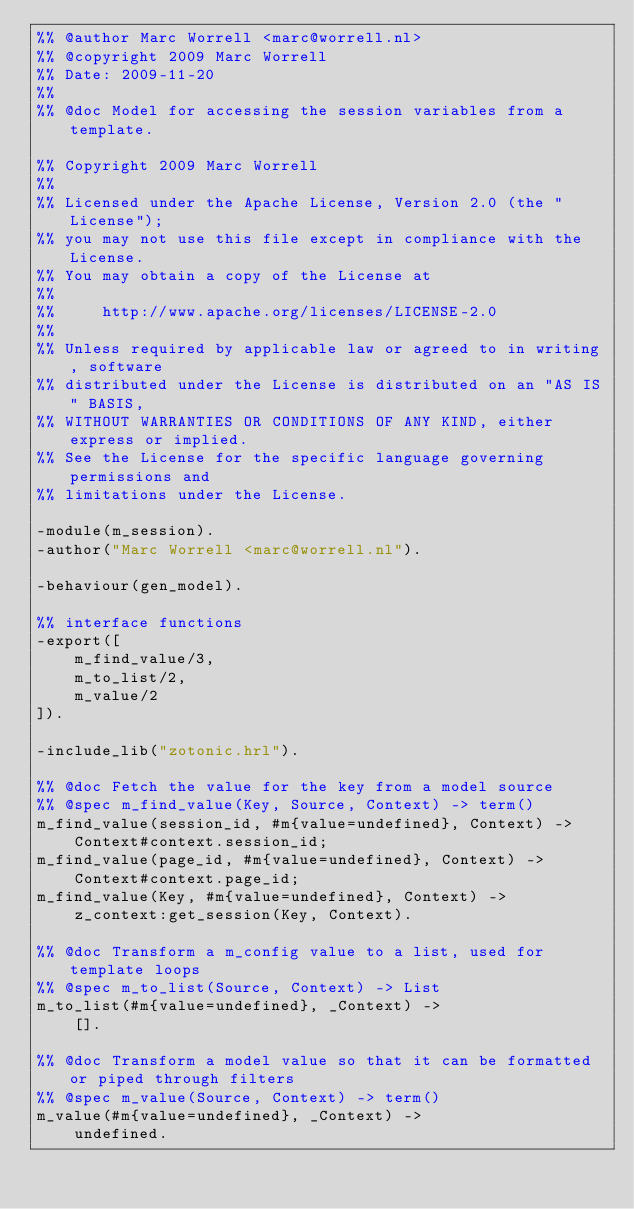Convert code to text. <code><loc_0><loc_0><loc_500><loc_500><_Erlang_>%% @author Marc Worrell <marc@worrell.nl>
%% @copyright 2009 Marc Worrell
%% Date: 2009-11-20
%%
%% @doc Model for accessing the session variables from a template.

%% Copyright 2009 Marc Worrell
%%
%% Licensed under the Apache License, Version 2.0 (the "License");
%% you may not use this file except in compliance with the License.
%% You may obtain a copy of the License at
%%
%%     http://www.apache.org/licenses/LICENSE-2.0
%%
%% Unless required by applicable law or agreed to in writing, software
%% distributed under the License is distributed on an "AS IS" BASIS,
%% WITHOUT WARRANTIES OR CONDITIONS OF ANY KIND, either express or implied.
%% See the License for the specific language governing permissions and
%% limitations under the License.

-module(m_session).
-author("Marc Worrell <marc@worrell.nl").

-behaviour(gen_model).

%% interface functions
-export([
    m_find_value/3,
    m_to_list/2,
    m_value/2
]).

-include_lib("zotonic.hrl").

%% @doc Fetch the value for the key from a model source
%% @spec m_find_value(Key, Source, Context) -> term()
m_find_value(session_id, #m{value=undefined}, Context) ->
    Context#context.session_id;
m_find_value(page_id, #m{value=undefined}, Context) ->
    Context#context.page_id;
m_find_value(Key, #m{value=undefined}, Context) ->
    z_context:get_session(Key, Context).

%% @doc Transform a m_config value to a list, used for template loops
%% @spec m_to_list(Source, Context) -> List
m_to_list(#m{value=undefined}, _Context) ->
	[].

%% @doc Transform a model value so that it can be formatted or piped through filters
%% @spec m_value(Source, Context) -> term()
m_value(#m{value=undefined}, _Context) ->
	undefined.

</code> 